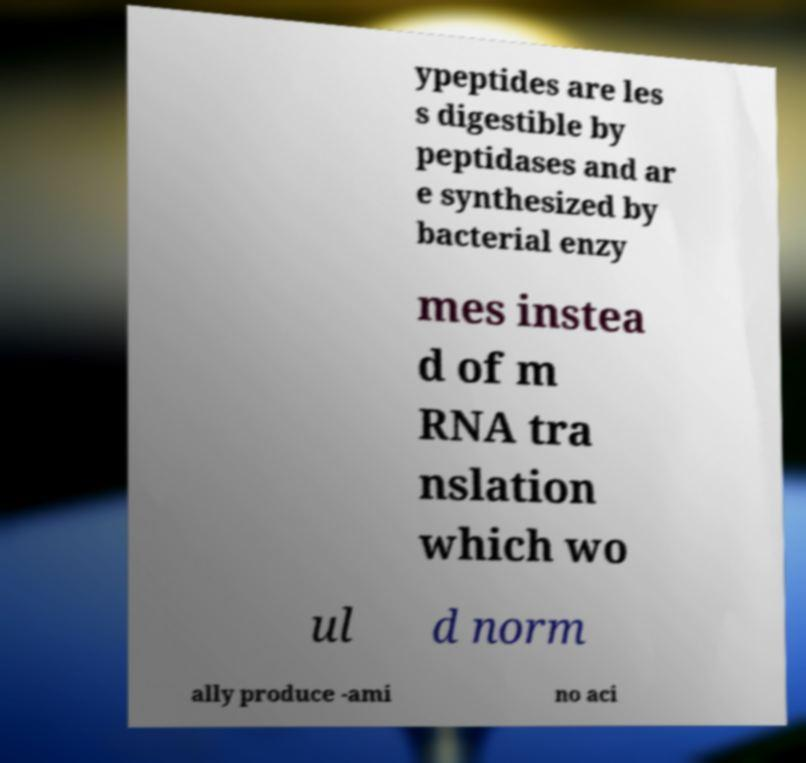Could you extract and type out the text from this image? ypeptides are les s digestible by peptidases and ar e synthesized by bacterial enzy mes instea d of m RNA tra nslation which wo ul d norm ally produce -ami no aci 